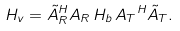<formula> <loc_0><loc_0><loc_500><loc_500>{ H _ { v } } = { \tilde { A } _ { R } } ^ { H } { A _ { R } \, H _ { b } \, } { A _ { T } } ^ { H } { \tilde { A } _ { T } } .</formula> 